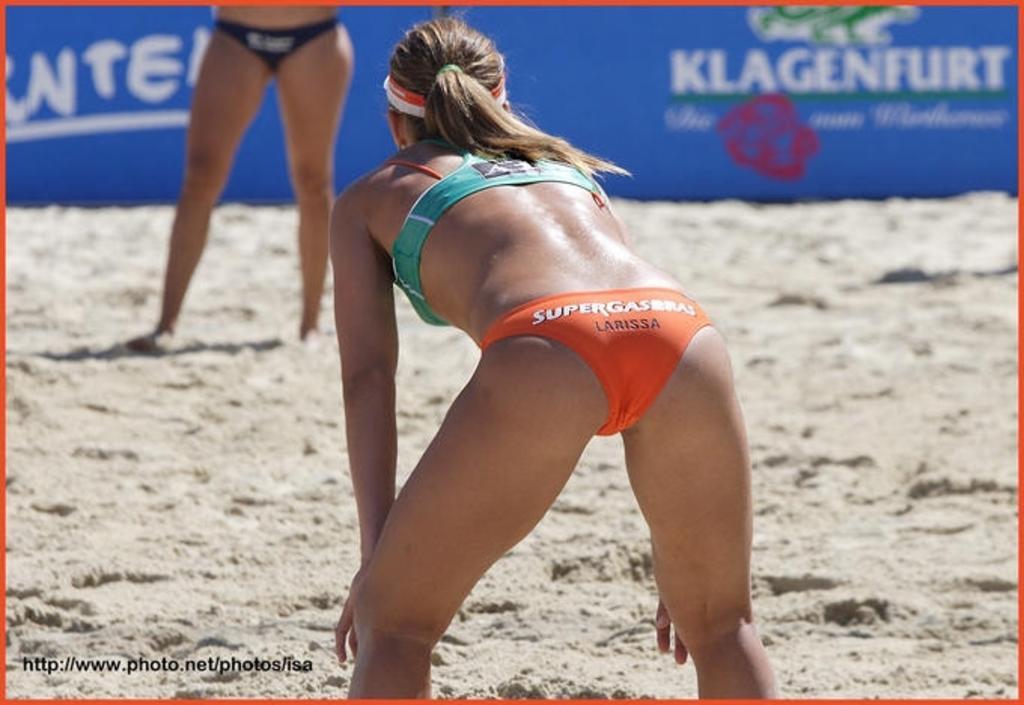Describe this image in one or two sentences. In this image I can see a person standing wearing green and orange color dress. Background I can see the other person standing and I can see blue color banner. 